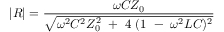<formula> <loc_0><loc_0><loc_500><loc_500>| R | = { \frac { \omega C Z _ { 0 } } { \sqrt { \omega ^ { 2 } C ^ { 2 } Z _ { 0 } ^ { 2 } + 4 ( 1 - \omega ^ { 2 } L C ) ^ { 2 } } } }</formula> 